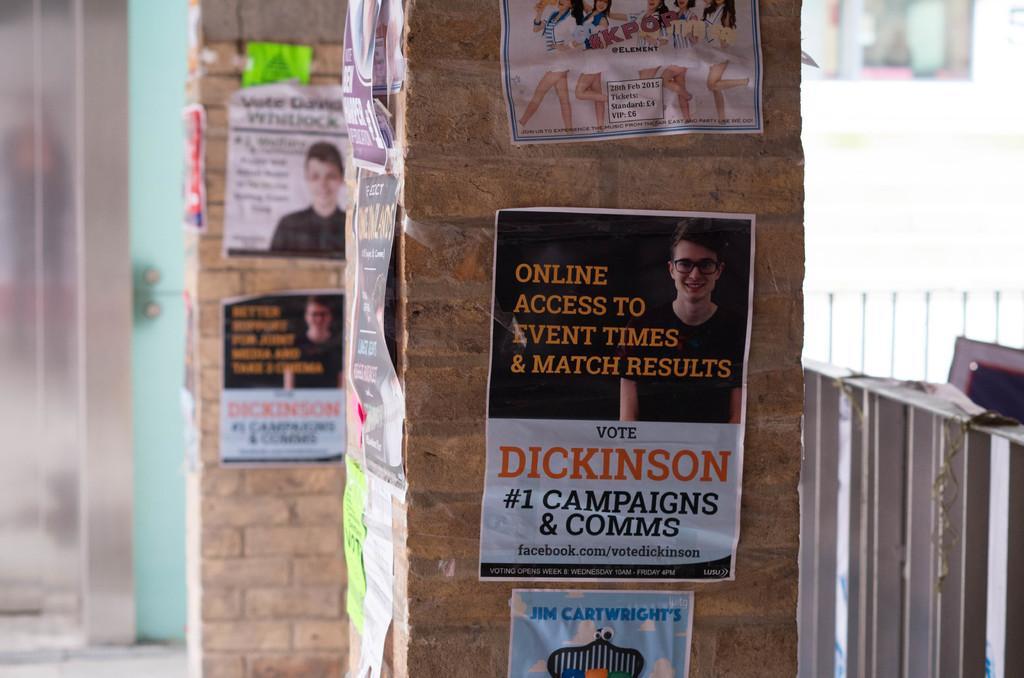Could you give a brief overview of what you see in this image? In this picture we can observe two pillars. There are some posters attached to these two pillars. On the right side we can observe a railing. These pillars are in cream color. The background is blurred. 